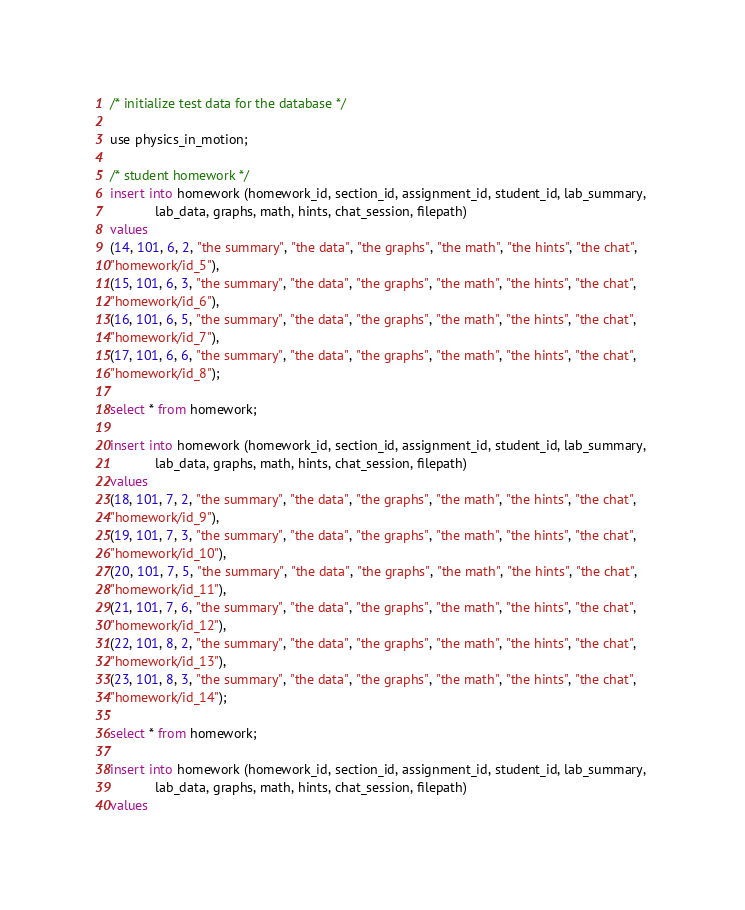<code> <loc_0><loc_0><loc_500><loc_500><_SQL_>/* initialize test data for the database */

use physics_in_motion;

/* student homework */
insert into homework (homework_id, section_id, assignment_id, student_id, lab_summary, 
			lab_data, graphs, math, hints, chat_session, filepath)
values 
(14, 101, 6, 2, "the summary", "the data", "the graphs", "the math", "the hints", "the chat",
"homework/id_5"),
(15, 101, 6, 3, "the summary", "the data", "the graphs", "the math", "the hints", "the chat",
"homework/id_6"),
(16, 101, 6, 5, "the summary", "the data", "the graphs", "the math", "the hints", "the chat",
"homework/id_7"),
(17, 101, 6, 6, "the summary", "the data", "the graphs", "the math", "the hints", "the chat",
"homework/id_8");

select * from homework;

insert into homework (homework_id, section_id, assignment_id, student_id, lab_summary, 
			lab_data, graphs, math, hints, chat_session, filepath)
values 
(18, 101, 7, 2, "the summary", "the data", "the graphs", "the math", "the hints", "the chat",
"homework/id_9"),
(19, 101, 7, 3, "the summary", "the data", "the graphs", "the math", "the hints", "the chat",
"homework/id_10"),
(20, 101, 7, 5, "the summary", "the data", "the graphs", "the math", "the hints", "the chat",
"homework/id_11"),
(21, 101, 7, 6, "the summary", "the data", "the graphs", "the math", "the hints", "the chat",
"homework/id_12"),
(22, 101, 8, 2, "the summary", "the data", "the graphs", "the math", "the hints", "the chat",
"homework/id_13"),
(23, 101, 8, 3, "the summary", "the data", "the graphs", "the math", "the hints", "the chat",
"homework/id_14");

select * from homework;

insert into homework (homework_id, section_id, assignment_id, student_id, lab_summary, 
			lab_data, graphs, math, hints, chat_session, filepath)
values </code> 